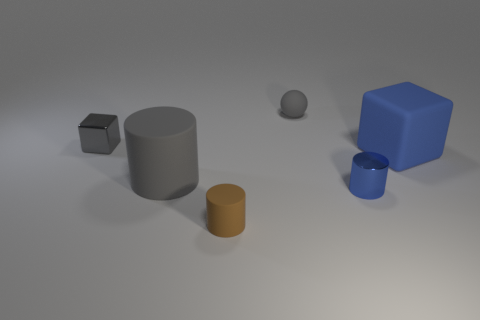Subtract all rubber cylinders. How many cylinders are left? 1 Add 1 purple metallic cylinders. How many objects exist? 7 Subtract all balls. How many objects are left? 5 Add 1 tiny cyan balls. How many tiny cyan balls exist? 1 Subtract 0 yellow blocks. How many objects are left? 6 Subtract all small purple spheres. Subtract all spheres. How many objects are left? 5 Add 1 gray objects. How many gray objects are left? 4 